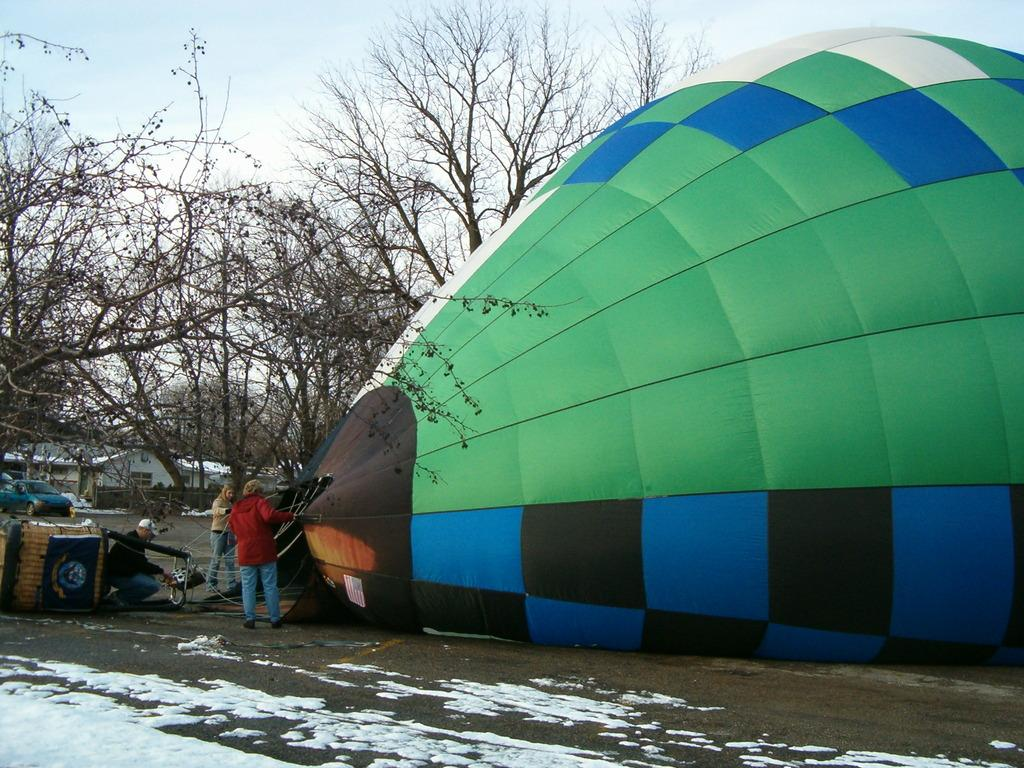What is the main object in the image? There is a parachute in the image. Who is present near the parachute? There are multiple persons standing beside the parachute. What can be seen at the bottom of the image? There is a road at the bottom of the image. What is the condition of the road? Snow is present on the road. What is visible in the background of the image? There are trees in the background of the image. What type of class is being held in the wilderness in the image? There is no class or wilderness present in the image; it features a parachute with people standing beside it, a snow-covered road, and trees in the background. 